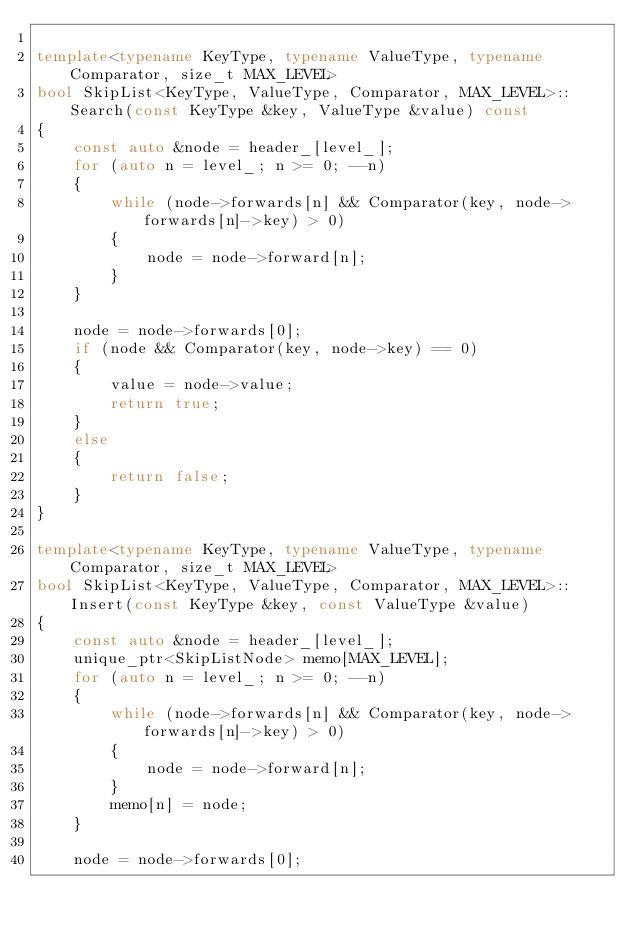Convert code to text. <code><loc_0><loc_0><loc_500><loc_500><_C++_>    
template<typename KeyType, typename ValueType, typename Comparator, size_t MAX_LEVEL>
bool SkipList<KeyType, ValueType, Comparator, MAX_LEVEL>::Search(const KeyType &key, ValueType &value) const
{
    const auto &node = header_[level_];
    for (auto n = level_; n >= 0; --n)
    {
        while (node->forwards[n] && Comparator(key, node->forwards[n]->key) > 0)
        {
            node = node->forward[n];
        }
    }
    
    node = node->forwards[0];
    if (node && Comparator(key, node->key) == 0)
    {
        value = node->value;
        return true;
    }
    else
    {
        return false;
    }
}

template<typename KeyType, typename ValueType, typename Comparator, size_t MAX_LEVEL>
bool SkipList<KeyType, ValueType, Comparator, MAX_LEVEL>::Insert(const KeyType &key, const ValueType &value)
{
    const auto &node = header_[level_];
    unique_ptr<SkipListNode> memo[MAX_LEVEL];
    for (auto n = level_; n >= 0; --n)
    {
        while (node->forwards[n] && Comparator(key, node->forwards[n]->key) > 0)
        {
            node = node->forward[n];
        }
        memo[n] = node;
    }
    
    node = node->forwards[0];</code> 